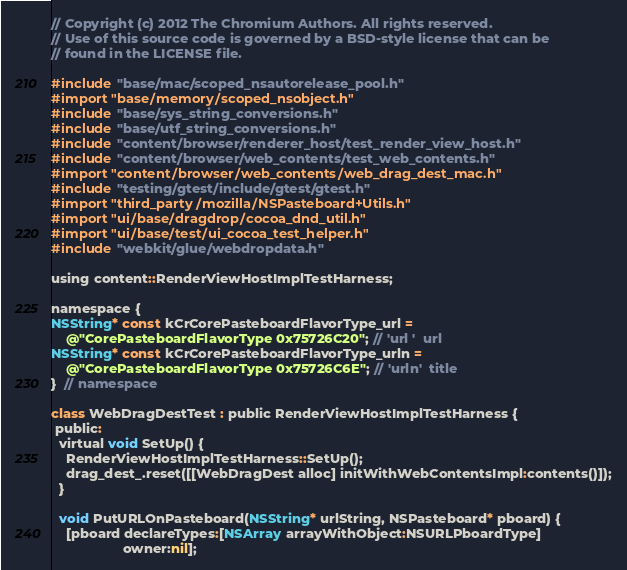<code> <loc_0><loc_0><loc_500><loc_500><_ObjectiveC_>// Copyright (c) 2012 The Chromium Authors. All rights reserved.
// Use of this source code is governed by a BSD-style license that can be
// found in the LICENSE file.

#include "base/mac/scoped_nsautorelease_pool.h"
#import "base/memory/scoped_nsobject.h"
#include "base/sys_string_conversions.h"
#include "base/utf_string_conversions.h"
#include "content/browser/renderer_host/test_render_view_host.h"
#include "content/browser/web_contents/test_web_contents.h"
#import "content/browser/web_contents/web_drag_dest_mac.h"
#include "testing/gtest/include/gtest/gtest.h"
#import "third_party/mozilla/NSPasteboard+Utils.h"
#import "ui/base/dragdrop/cocoa_dnd_util.h"
#import "ui/base/test/ui_cocoa_test_helper.h"
#include "webkit/glue/webdropdata.h"

using content::RenderViewHostImplTestHarness;

namespace {
NSString* const kCrCorePasteboardFlavorType_url =
    @"CorePasteboardFlavorType 0x75726C20"; // 'url '  url
NSString* const kCrCorePasteboardFlavorType_urln =
    @"CorePasteboardFlavorType 0x75726C6E"; // 'urln'  title
}  // namespace

class WebDragDestTest : public RenderViewHostImplTestHarness {
 public:
  virtual void SetUp() {
    RenderViewHostImplTestHarness::SetUp();
    drag_dest_.reset([[WebDragDest alloc] initWithWebContentsImpl:contents()]);
  }

  void PutURLOnPasteboard(NSString* urlString, NSPasteboard* pboard) {
    [pboard declareTypes:[NSArray arrayWithObject:NSURLPboardType]
                   owner:nil];</code> 